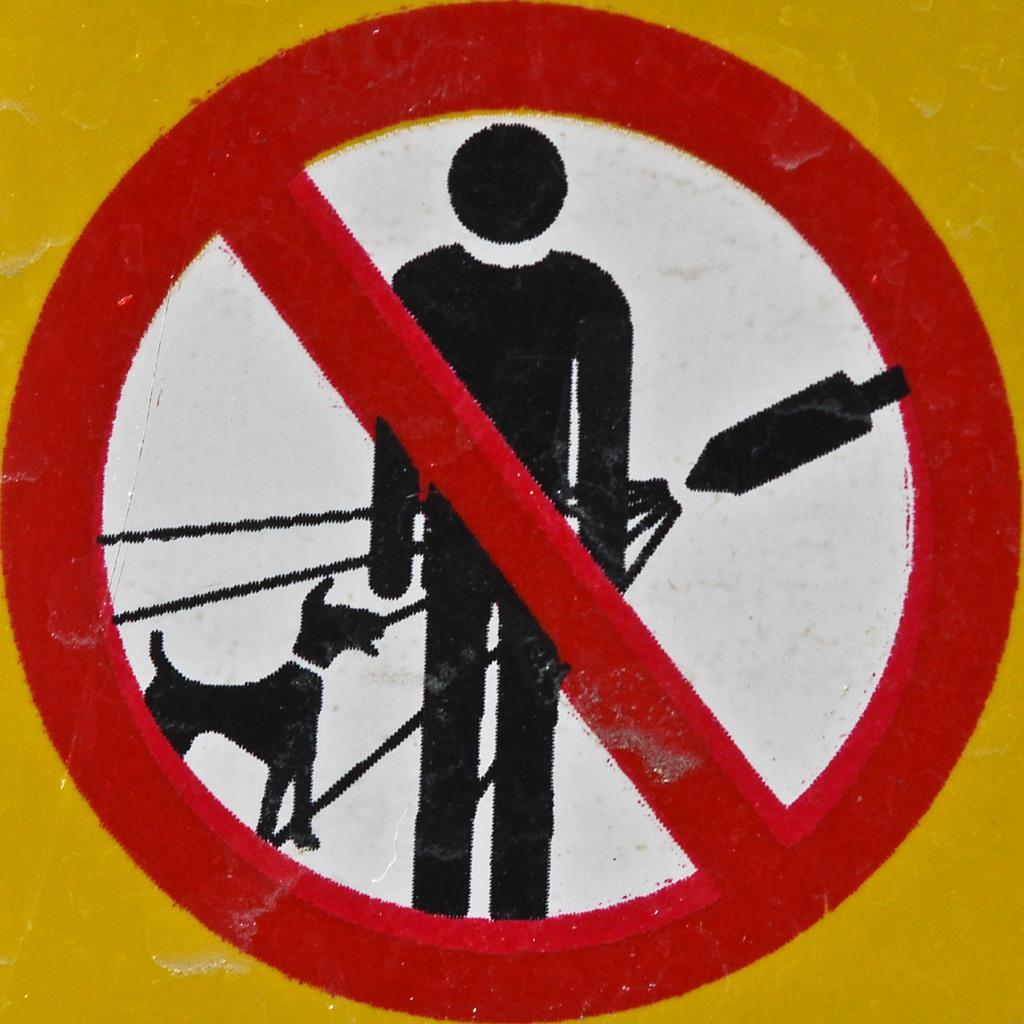What is the main object in the image? There is a sign board in the image. What type of hair can be seen on the sign board in the image? There is no hair present on the sign board in the image. 